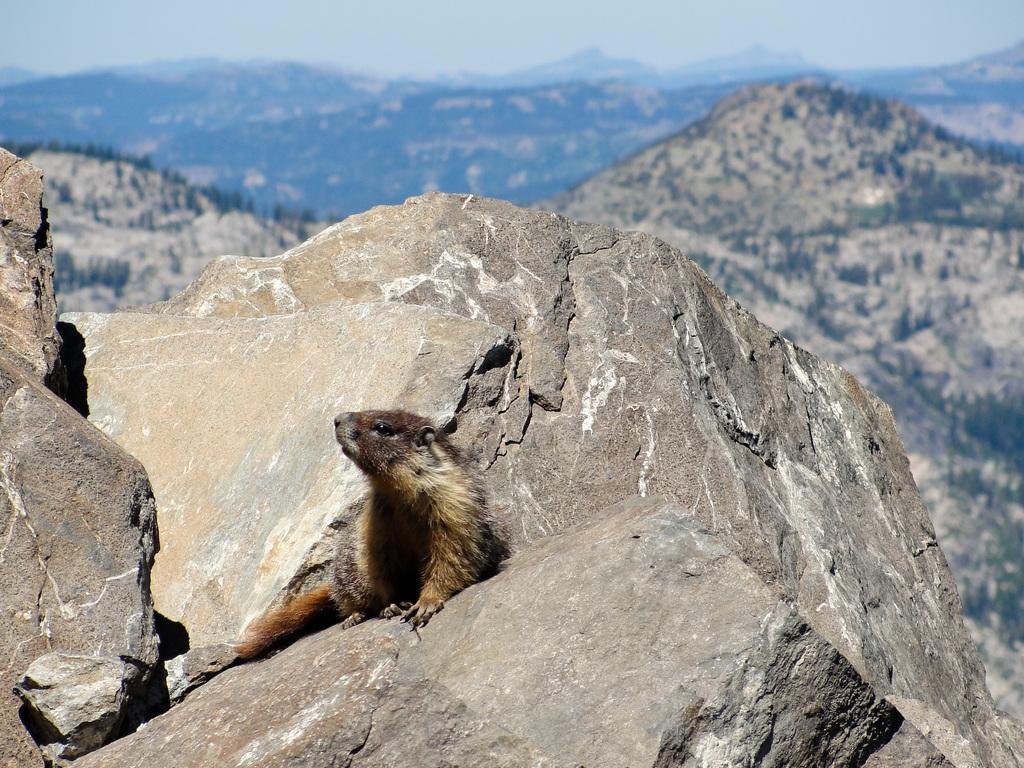Please provide a concise description of this image. In this image there is a beaver sitting on the stone. In the background there are mountains on which there are trees. 